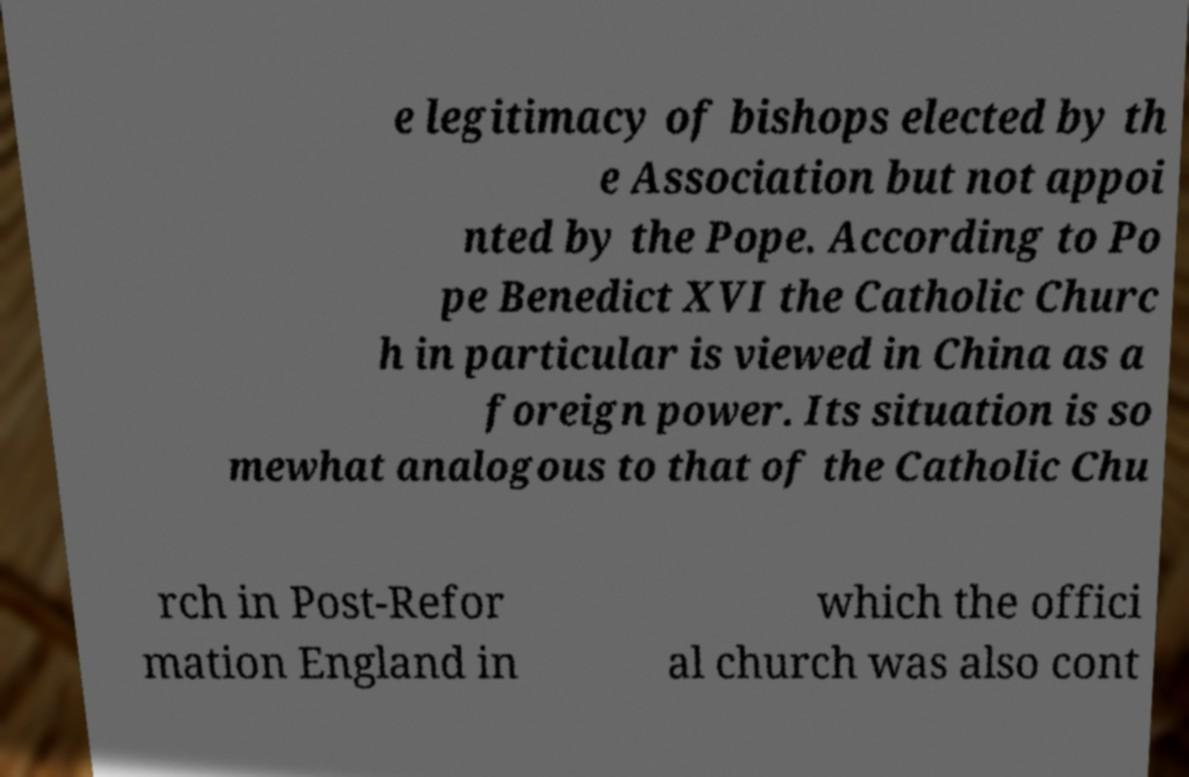Could you assist in decoding the text presented in this image and type it out clearly? e legitimacy of bishops elected by th e Association but not appoi nted by the Pope. According to Po pe Benedict XVI the Catholic Churc h in particular is viewed in China as a foreign power. Its situation is so mewhat analogous to that of the Catholic Chu rch in Post-Refor mation England in which the offici al church was also cont 